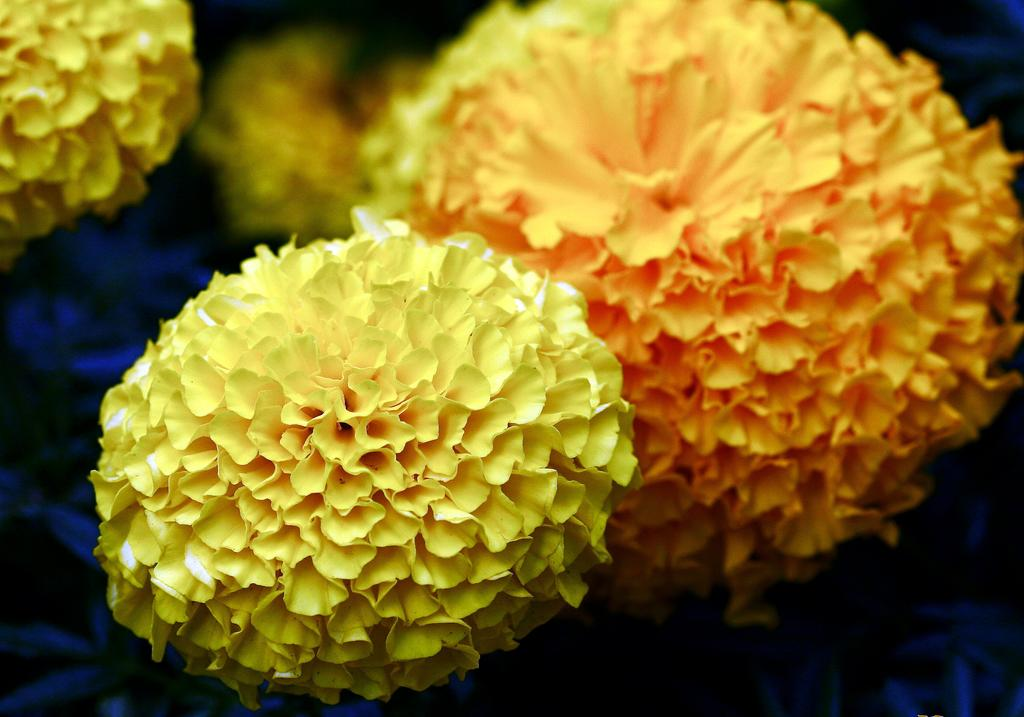What type of living organisms can be seen in the image? Flowers can be seen in the image. What activity is the robin performing in the image? There is no robin present in the image; it only features flowers. How is the flower being used in the image? The question is unclear as flowers are not typically used for a specific purpose in an image. Flowers are usually depicted for their aesthetic or symbolic value. 